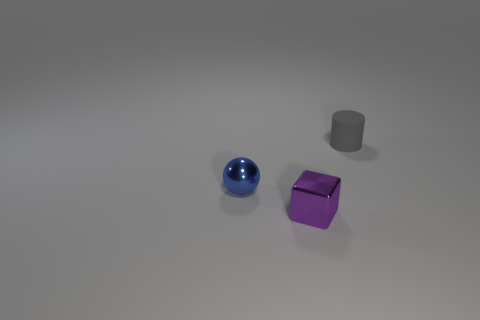What color is the object that is right of the metal object that is in front of the ball?
Provide a succinct answer. Gray. What color is the metallic object behind the small metallic object to the right of the tiny metallic object that is to the left of the tiny block?
Ensure brevity in your answer.  Blue. What number of things are small rubber objects or blue objects?
Provide a succinct answer. 2. What number of other blue metallic objects have the same shape as the blue object?
Make the answer very short. 0. Are the ball and the small object in front of the sphere made of the same material?
Offer a terse response. Yes. There is a purple cube that is the same material as the tiny sphere; what size is it?
Provide a short and direct response. Small. There is a object left of the block; how big is it?
Offer a terse response. Small. How many blue shiny objects have the same size as the gray rubber object?
Ensure brevity in your answer.  1. Is there a small shiny sphere of the same color as the matte object?
Provide a succinct answer. No. There is a cylinder that is the same size as the metal cube; what is its color?
Ensure brevity in your answer.  Gray. 